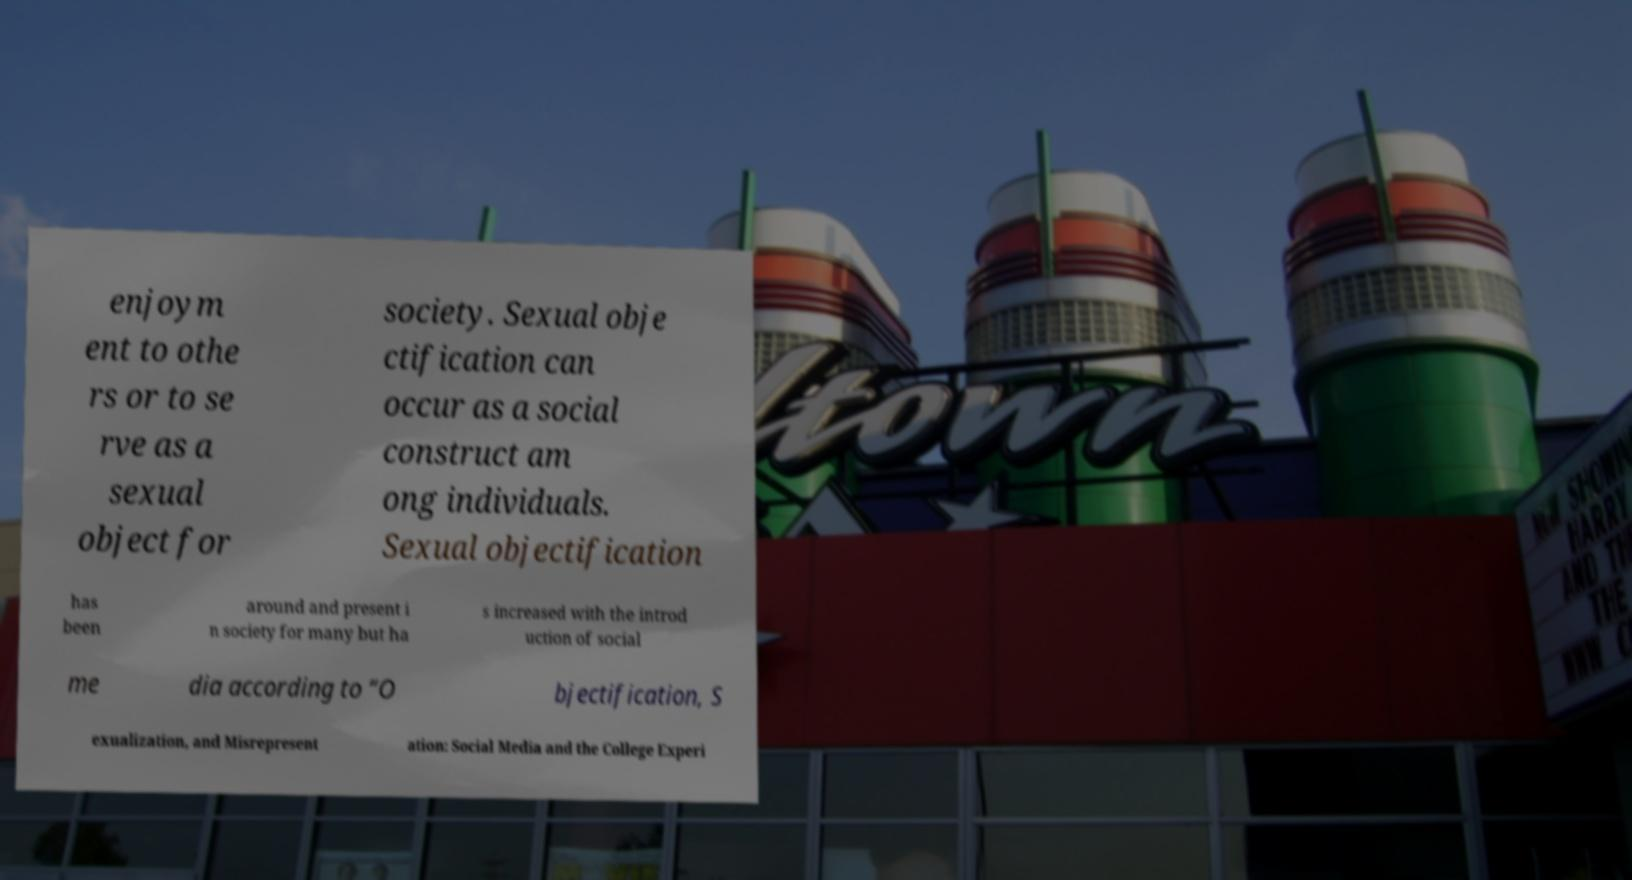Can you accurately transcribe the text from the provided image for me? enjoym ent to othe rs or to se rve as a sexual object for society. Sexual obje ctification can occur as a social construct am ong individuals. Sexual objectification has been around and present i n society for many but ha s increased with the introd uction of social me dia according to “O bjectification, S exualization, and Misrepresent ation: Social Media and the College Experi 